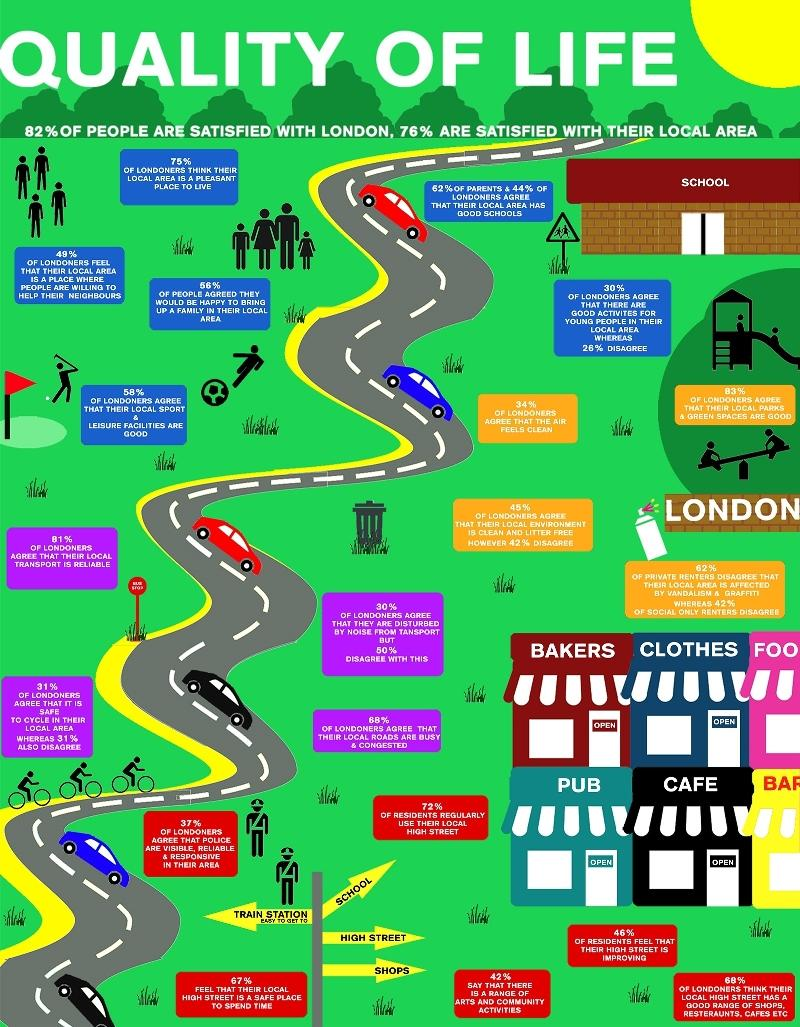Specify some key components in this picture. A significant majority, 63%, of Londoners disagree that police are visible in their area. There are 6 cars featured in this infographic. This infographic contains 3 cycles. According to the survey, 28% of the residents did not use their local high street regularly. 